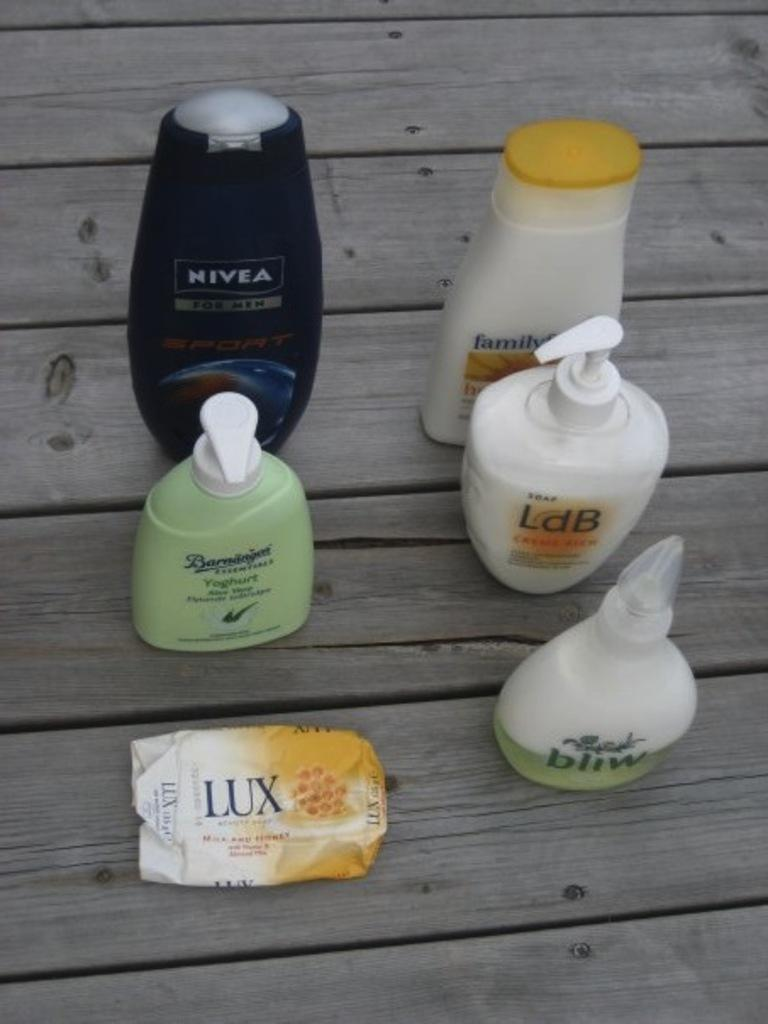What is the main object in the image? There is a wooden plank in the image. What items are placed on the wooden plank? There are five hair conditioner bottles and a soap cover on the wooden plank. How does the wooden plank slip through the hole in the image? There is no hole present in the image, and the wooden plank does not slip through anything. 